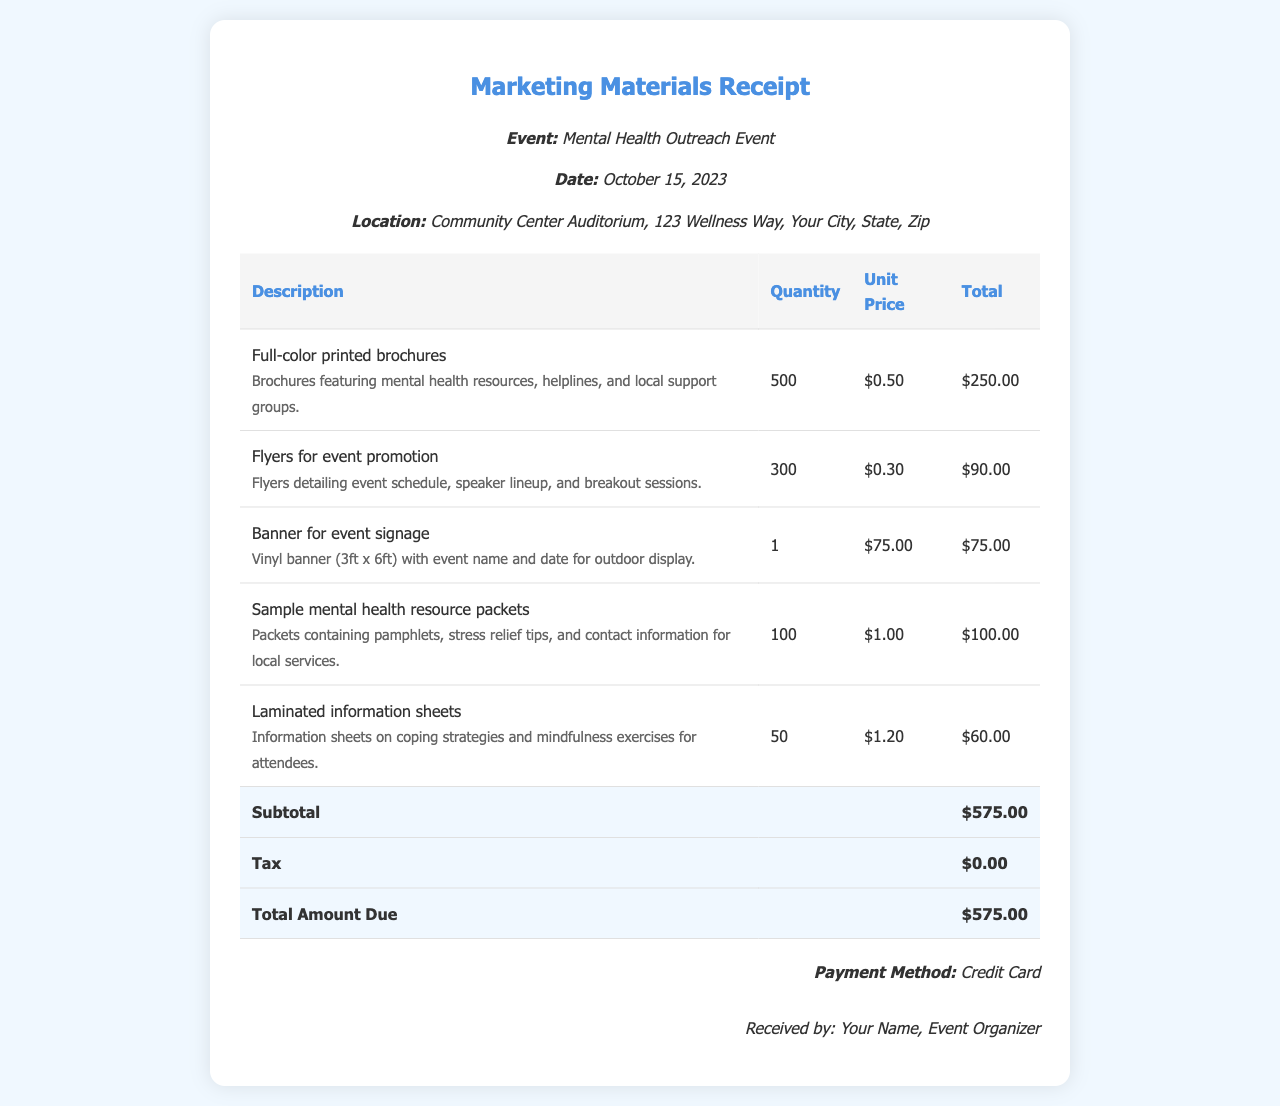What is the event date? The event date is specified as October 15, 2023 in the document.
Answer: October 15, 2023 How many brochures were printed? The quantity of printed brochures is listed as 500 in the itemized costs.
Answer: 500 What is the total amount due? The total amount due is found in the total row of the receipt, which states $575.00.
Answer: $575.00 What type of payment was used? The payment method is mentioned in the document as Credit Card.
Answer: Credit Card What is the cost of the vinyl banner? The unit price for the vinyl banner is provided in the itemized list as $75.00.
Answer: $75.00 How many flyers were printed? The number of flyers printed is indicated as 300 in the document.
Answer: 300 What is included in the sample mental health resource packets? The document mentions that packets contain pamphlets, stress relief tips, and contact information for local services.
Answer: Pamphlets, stress relief tips, contact information What is the subtotal before tax? The subtotal before tax is clearly shown in the total row, which is $575.00.
Answer: $575.00 What type of items are laminated information sheets? These sheets are described as information sheets on coping strategies and mindfulness exercises.
Answer: Coping strategies and mindfulness exercises 